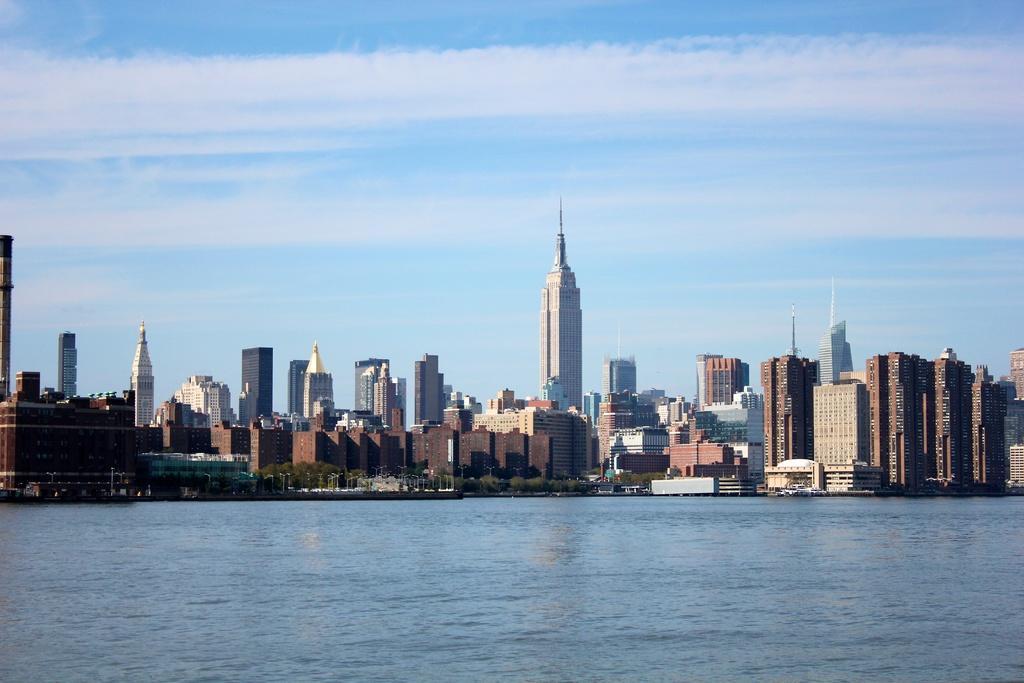Describe this image in one or two sentences. There is water. In the background, there are trees and buildings on the ground and there are clouds in the blue sky. 